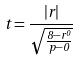<formula> <loc_0><loc_0><loc_500><loc_500>t = \frac { | r | } { \sqrt { \frac { 8 - r ^ { 0 } } { p - 0 } } }</formula> 